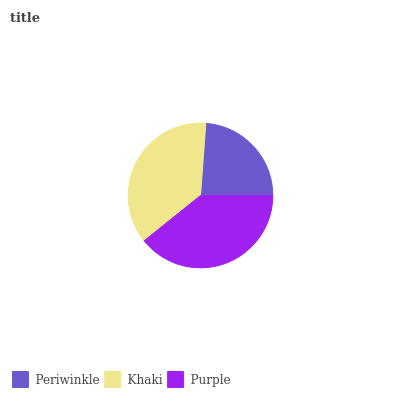Is Periwinkle the minimum?
Answer yes or no. Yes. Is Purple the maximum?
Answer yes or no. Yes. Is Khaki the minimum?
Answer yes or no. No. Is Khaki the maximum?
Answer yes or no. No. Is Khaki greater than Periwinkle?
Answer yes or no. Yes. Is Periwinkle less than Khaki?
Answer yes or no. Yes. Is Periwinkle greater than Khaki?
Answer yes or no. No. Is Khaki less than Periwinkle?
Answer yes or no. No. Is Khaki the high median?
Answer yes or no. Yes. Is Khaki the low median?
Answer yes or no. Yes. Is Periwinkle the high median?
Answer yes or no. No. Is Periwinkle the low median?
Answer yes or no. No. 